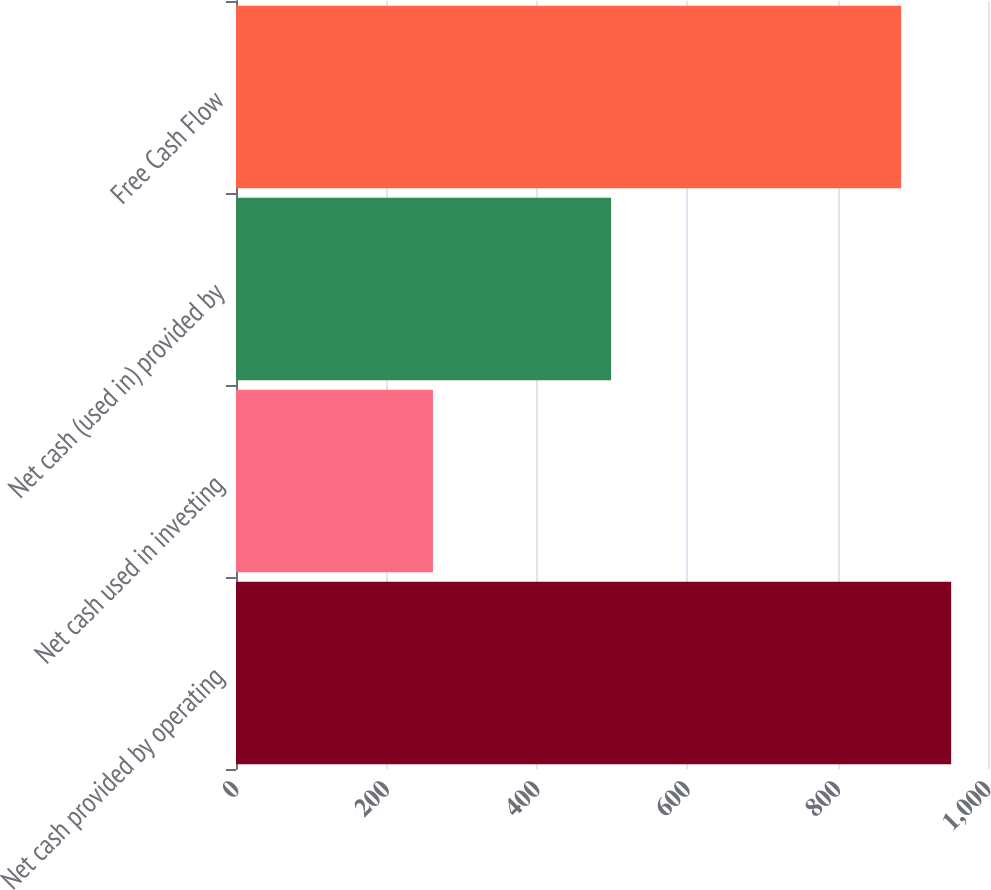Convert chart. <chart><loc_0><loc_0><loc_500><loc_500><bar_chart><fcel>Net cash provided by operating<fcel>Net cash used in investing<fcel>Net cash (used in) provided by<fcel>Free Cash Flow<nl><fcel>950.99<fcel>261.9<fcel>498.8<fcel>884.5<nl></chart> 